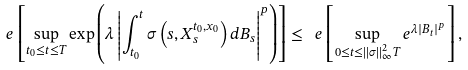<formula> <loc_0><loc_0><loc_500><loc_500>\ e \left [ \sup _ { t _ { 0 } \leq t \leq T } \exp \left ( \lambda \left | \int _ { t _ { 0 } } ^ { t } \sigma \left ( s , X ^ { t _ { 0 } , x _ { 0 } } _ { s } \right ) d B _ { s } \right | ^ { p } \right ) \right ] \leq \ e \left [ \sup _ { 0 \leq t \leq \| \sigma \| _ { \infty } ^ { 2 } T } e ^ { \lambda | B _ { t } | ^ { p } } \right ] ,</formula> 